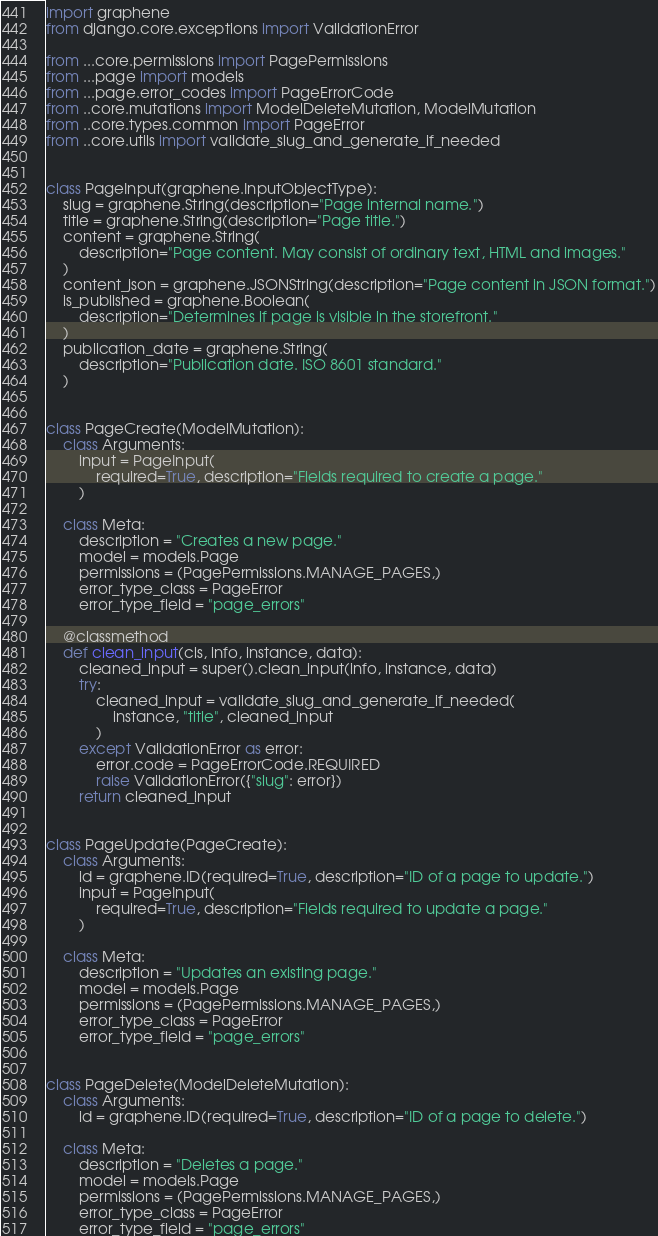<code> <loc_0><loc_0><loc_500><loc_500><_Python_>import graphene
from django.core.exceptions import ValidationError

from ...core.permissions import PagePermissions
from ...page import models
from ...page.error_codes import PageErrorCode
from ..core.mutations import ModelDeleteMutation, ModelMutation
from ..core.types.common import PageError
from ..core.utils import validate_slug_and_generate_if_needed


class PageInput(graphene.InputObjectType):
    slug = graphene.String(description="Page internal name.")
    title = graphene.String(description="Page title.")
    content = graphene.String(
        description="Page content. May consist of ordinary text, HTML and images."
    )
    content_json = graphene.JSONString(description="Page content in JSON format.")
    is_published = graphene.Boolean(
        description="Determines if page is visible in the storefront."
    )
    publication_date = graphene.String(
        description="Publication date. ISO 8601 standard."
    )


class PageCreate(ModelMutation):
    class Arguments:
        input = PageInput(
            required=True, description="Fields required to create a page."
        )

    class Meta:
        description = "Creates a new page."
        model = models.Page
        permissions = (PagePermissions.MANAGE_PAGES,)
        error_type_class = PageError
        error_type_field = "page_errors"

    @classmethod
    def clean_input(cls, info, instance, data):
        cleaned_input = super().clean_input(info, instance, data)
        try:
            cleaned_input = validate_slug_and_generate_if_needed(
                instance, "title", cleaned_input
            )
        except ValidationError as error:
            error.code = PageErrorCode.REQUIRED
            raise ValidationError({"slug": error})
        return cleaned_input


class PageUpdate(PageCreate):
    class Arguments:
        id = graphene.ID(required=True, description="ID of a page to update.")
        input = PageInput(
            required=True, description="Fields required to update a page."
        )

    class Meta:
        description = "Updates an existing page."
        model = models.Page
        permissions = (PagePermissions.MANAGE_PAGES,)
        error_type_class = PageError
        error_type_field = "page_errors"


class PageDelete(ModelDeleteMutation):
    class Arguments:
        id = graphene.ID(required=True, description="ID of a page to delete.")

    class Meta:
        description = "Deletes a page."
        model = models.Page
        permissions = (PagePermissions.MANAGE_PAGES,)
        error_type_class = PageError
        error_type_field = "page_errors"
</code> 